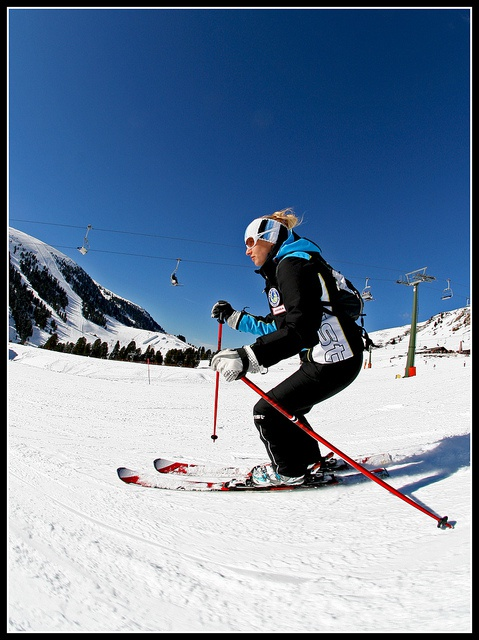Describe the objects in this image and their specific colors. I can see people in black, lightgray, darkgray, and gray tones, skis in black, lightgray, darkgray, and gray tones, and backpack in black, darkgray, blue, and gray tones in this image. 